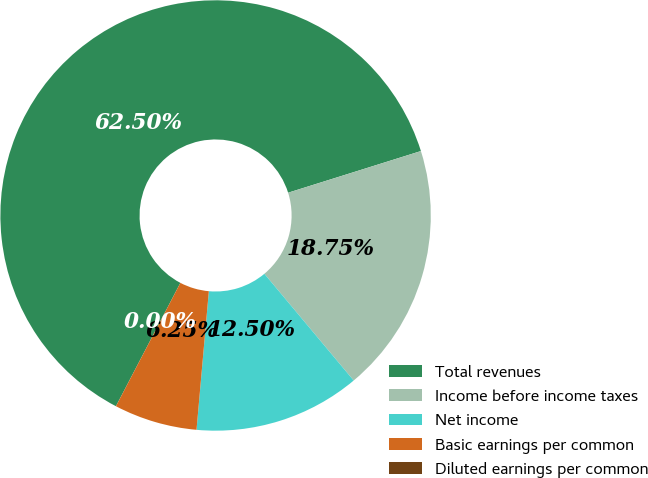Convert chart to OTSL. <chart><loc_0><loc_0><loc_500><loc_500><pie_chart><fcel>Total revenues<fcel>Income before income taxes<fcel>Net income<fcel>Basic earnings per common<fcel>Diluted earnings per common<nl><fcel>62.5%<fcel>18.75%<fcel>12.5%<fcel>6.25%<fcel>0.0%<nl></chart> 